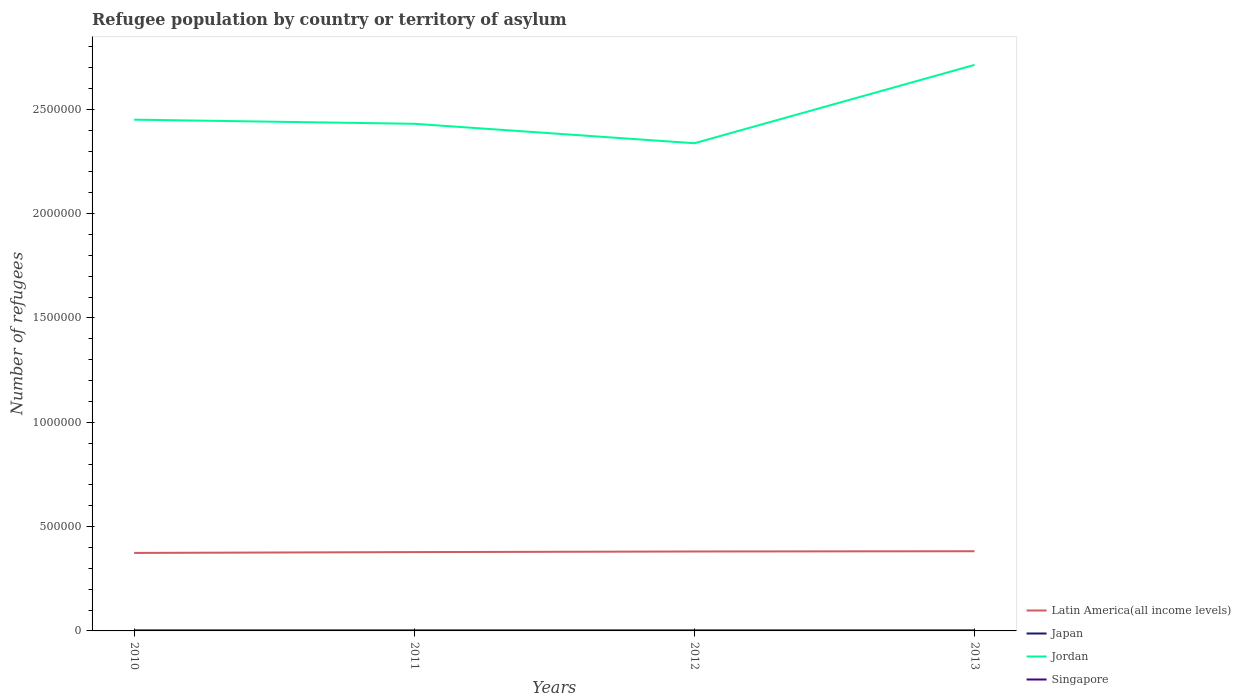Does the line corresponding to Japan intersect with the line corresponding to Jordan?
Your answer should be very brief. No. Is the number of lines equal to the number of legend labels?
Keep it short and to the point. Yes. Across all years, what is the maximum number of refugees in Latin America(all income levels)?
Your answer should be compact. 3.74e+05. What is the total number of refugees in Latin America(all income levels) in the graph?
Ensure brevity in your answer.  -1213. What is the difference between the highest and the second highest number of refugees in Japan?
Your answer should be compact. 68. How many lines are there?
Your answer should be compact. 4. Does the graph contain any zero values?
Give a very brief answer. No. Does the graph contain grids?
Provide a succinct answer. No. How are the legend labels stacked?
Your response must be concise. Vertical. What is the title of the graph?
Your answer should be compact. Refugee population by country or territory of asylum. Does "St. Vincent and the Grenadines" appear as one of the legend labels in the graph?
Provide a succinct answer. No. What is the label or title of the X-axis?
Ensure brevity in your answer.  Years. What is the label or title of the Y-axis?
Ensure brevity in your answer.  Number of refugees. What is the Number of refugees in Latin America(all income levels) in 2010?
Provide a succinct answer. 3.74e+05. What is the Number of refugees of Japan in 2010?
Keep it short and to the point. 2586. What is the Number of refugees in Jordan in 2010?
Your response must be concise. 2.45e+06. What is the Number of refugees of Singapore in 2010?
Give a very brief answer. 7. What is the Number of refugees of Latin America(all income levels) in 2011?
Offer a terse response. 3.78e+05. What is the Number of refugees of Japan in 2011?
Your answer should be very brief. 2649. What is the Number of refugees of Jordan in 2011?
Provide a succinct answer. 2.43e+06. What is the Number of refugees of Latin America(all income levels) in 2012?
Provide a short and direct response. 3.81e+05. What is the Number of refugees in Japan in 2012?
Keep it short and to the point. 2581. What is the Number of refugees in Jordan in 2012?
Your response must be concise. 2.34e+06. What is the Number of refugees in Latin America(all income levels) in 2013?
Give a very brief answer. 3.82e+05. What is the Number of refugees in Japan in 2013?
Make the answer very short. 2584. What is the Number of refugees of Jordan in 2013?
Provide a short and direct response. 2.71e+06. What is the Number of refugees of Singapore in 2013?
Ensure brevity in your answer.  3. Across all years, what is the maximum Number of refugees in Latin America(all income levels)?
Provide a succinct answer. 3.82e+05. Across all years, what is the maximum Number of refugees in Japan?
Provide a short and direct response. 2649. Across all years, what is the maximum Number of refugees in Jordan?
Ensure brevity in your answer.  2.71e+06. Across all years, what is the maximum Number of refugees of Singapore?
Provide a short and direct response. 7. Across all years, what is the minimum Number of refugees in Latin America(all income levels)?
Provide a succinct answer. 3.74e+05. Across all years, what is the minimum Number of refugees of Japan?
Ensure brevity in your answer.  2581. Across all years, what is the minimum Number of refugees in Jordan?
Your answer should be very brief. 2.34e+06. Across all years, what is the minimum Number of refugees in Singapore?
Your answer should be compact. 3. What is the total Number of refugees in Latin America(all income levels) in the graph?
Provide a succinct answer. 1.51e+06. What is the total Number of refugees of Japan in the graph?
Ensure brevity in your answer.  1.04e+04. What is the total Number of refugees in Jordan in the graph?
Offer a very short reply. 9.93e+06. What is the total Number of refugees in Singapore in the graph?
Offer a very short reply. 16. What is the difference between the Number of refugees of Latin America(all income levels) in 2010 and that in 2011?
Ensure brevity in your answer.  -3917. What is the difference between the Number of refugees of Japan in 2010 and that in 2011?
Ensure brevity in your answer.  -63. What is the difference between the Number of refugees in Jordan in 2010 and that in 2011?
Offer a terse response. 1.98e+04. What is the difference between the Number of refugees in Singapore in 2010 and that in 2011?
Your answer should be very brief. 4. What is the difference between the Number of refugees of Latin America(all income levels) in 2010 and that in 2012?
Your answer should be very brief. -6871. What is the difference between the Number of refugees in Jordan in 2010 and that in 2012?
Offer a terse response. 1.13e+05. What is the difference between the Number of refugees of Singapore in 2010 and that in 2012?
Offer a very short reply. 4. What is the difference between the Number of refugees of Latin America(all income levels) in 2010 and that in 2013?
Provide a short and direct response. -8084. What is the difference between the Number of refugees of Japan in 2010 and that in 2013?
Offer a terse response. 2. What is the difference between the Number of refugees of Jordan in 2010 and that in 2013?
Provide a short and direct response. -2.63e+05. What is the difference between the Number of refugees of Latin America(all income levels) in 2011 and that in 2012?
Your answer should be very brief. -2954. What is the difference between the Number of refugees of Japan in 2011 and that in 2012?
Your answer should be very brief. 68. What is the difference between the Number of refugees in Jordan in 2011 and that in 2012?
Provide a short and direct response. 9.32e+04. What is the difference between the Number of refugees in Singapore in 2011 and that in 2012?
Make the answer very short. 0. What is the difference between the Number of refugees of Latin America(all income levels) in 2011 and that in 2013?
Provide a succinct answer. -4167. What is the difference between the Number of refugees in Japan in 2011 and that in 2013?
Offer a very short reply. 65. What is the difference between the Number of refugees in Jordan in 2011 and that in 2013?
Make the answer very short. -2.82e+05. What is the difference between the Number of refugees of Latin America(all income levels) in 2012 and that in 2013?
Give a very brief answer. -1213. What is the difference between the Number of refugees of Jordan in 2012 and that in 2013?
Ensure brevity in your answer.  -3.76e+05. What is the difference between the Number of refugees in Singapore in 2012 and that in 2013?
Your answer should be very brief. 0. What is the difference between the Number of refugees in Latin America(all income levels) in 2010 and the Number of refugees in Japan in 2011?
Provide a succinct answer. 3.71e+05. What is the difference between the Number of refugees in Latin America(all income levels) in 2010 and the Number of refugees in Jordan in 2011?
Your answer should be very brief. -2.06e+06. What is the difference between the Number of refugees of Latin America(all income levels) in 2010 and the Number of refugees of Singapore in 2011?
Provide a succinct answer. 3.74e+05. What is the difference between the Number of refugees in Japan in 2010 and the Number of refugees in Jordan in 2011?
Your answer should be compact. -2.43e+06. What is the difference between the Number of refugees of Japan in 2010 and the Number of refugees of Singapore in 2011?
Your answer should be compact. 2583. What is the difference between the Number of refugees of Jordan in 2010 and the Number of refugees of Singapore in 2011?
Give a very brief answer. 2.45e+06. What is the difference between the Number of refugees in Latin America(all income levels) in 2010 and the Number of refugees in Japan in 2012?
Keep it short and to the point. 3.71e+05. What is the difference between the Number of refugees of Latin America(all income levels) in 2010 and the Number of refugees of Jordan in 2012?
Your answer should be very brief. -1.96e+06. What is the difference between the Number of refugees in Latin America(all income levels) in 2010 and the Number of refugees in Singapore in 2012?
Give a very brief answer. 3.74e+05. What is the difference between the Number of refugees of Japan in 2010 and the Number of refugees of Jordan in 2012?
Ensure brevity in your answer.  -2.33e+06. What is the difference between the Number of refugees in Japan in 2010 and the Number of refugees in Singapore in 2012?
Offer a terse response. 2583. What is the difference between the Number of refugees in Jordan in 2010 and the Number of refugees in Singapore in 2012?
Ensure brevity in your answer.  2.45e+06. What is the difference between the Number of refugees in Latin America(all income levels) in 2010 and the Number of refugees in Japan in 2013?
Your response must be concise. 3.71e+05. What is the difference between the Number of refugees in Latin America(all income levels) in 2010 and the Number of refugees in Jordan in 2013?
Offer a terse response. -2.34e+06. What is the difference between the Number of refugees of Latin America(all income levels) in 2010 and the Number of refugees of Singapore in 2013?
Offer a terse response. 3.74e+05. What is the difference between the Number of refugees of Japan in 2010 and the Number of refugees of Jordan in 2013?
Give a very brief answer. -2.71e+06. What is the difference between the Number of refugees in Japan in 2010 and the Number of refugees in Singapore in 2013?
Ensure brevity in your answer.  2583. What is the difference between the Number of refugees in Jordan in 2010 and the Number of refugees in Singapore in 2013?
Your response must be concise. 2.45e+06. What is the difference between the Number of refugees of Latin America(all income levels) in 2011 and the Number of refugees of Japan in 2012?
Give a very brief answer. 3.75e+05. What is the difference between the Number of refugees in Latin America(all income levels) in 2011 and the Number of refugees in Jordan in 2012?
Your response must be concise. -1.96e+06. What is the difference between the Number of refugees of Latin America(all income levels) in 2011 and the Number of refugees of Singapore in 2012?
Offer a terse response. 3.78e+05. What is the difference between the Number of refugees in Japan in 2011 and the Number of refugees in Jordan in 2012?
Ensure brevity in your answer.  -2.33e+06. What is the difference between the Number of refugees of Japan in 2011 and the Number of refugees of Singapore in 2012?
Offer a terse response. 2646. What is the difference between the Number of refugees of Jordan in 2011 and the Number of refugees of Singapore in 2012?
Make the answer very short. 2.43e+06. What is the difference between the Number of refugees in Latin America(all income levels) in 2011 and the Number of refugees in Japan in 2013?
Ensure brevity in your answer.  3.75e+05. What is the difference between the Number of refugees of Latin America(all income levels) in 2011 and the Number of refugees of Jordan in 2013?
Provide a short and direct response. -2.34e+06. What is the difference between the Number of refugees of Latin America(all income levels) in 2011 and the Number of refugees of Singapore in 2013?
Ensure brevity in your answer.  3.78e+05. What is the difference between the Number of refugees of Japan in 2011 and the Number of refugees of Jordan in 2013?
Ensure brevity in your answer.  -2.71e+06. What is the difference between the Number of refugees in Japan in 2011 and the Number of refugees in Singapore in 2013?
Provide a succinct answer. 2646. What is the difference between the Number of refugees in Jordan in 2011 and the Number of refugees in Singapore in 2013?
Offer a terse response. 2.43e+06. What is the difference between the Number of refugees of Latin America(all income levels) in 2012 and the Number of refugees of Japan in 2013?
Provide a succinct answer. 3.78e+05. What is the difference between the Number of refugees in Latin America(all income levels) in 2012 and the Number of refugees in Jordan in 2013?
Ensure brevity in your answer.  -2.33e+06. What is the difference between the Number of refugees in Latin America(all income levels) in 2012 and the Number of refugees in Singapore in 2013?
Give a very brief answer. 3.81e+05. What is the difference between the Number of refugees of Japan in 2012 and the Number of refugees of Jordan in 2013?
Offer a very short reply. -2.71e+06. What is the difference between the Number of refugees in Japan in 2012 and the Number of refugees in Singapore in 2013?
Your response must be concise. 2578. What is the difference between the Number of refugees of Jordan in 2012 and the Number of refugees of Singapore in 2013?
Your response must be concise. 2.34e+06. What is the average Number of refugees of Latin America(all income levels) per year?
Provide a succinct answer. 3.79e+05. What is the average Number of refugees in Japan per year?
Offer a very short reply. 2600. What is the average Number of refugees of Jordan per year?
Your response must be concise. 2.48e+06. What is the average Number of refugees in Singapore per year?
Provide a succinct answer. 4. In the year 2010, what is the difference between the Number of refugees of Latin America(all income levels) and Number of refugees of Japan?
Give a very brief answer. 3.71e+05. In the year 2010, what is the difference between the Number of refugees in Latin America(all income levels) and Number of refugees in Jordan?
Make the answer very short. -2.08e+06. In the year 2010, what is the difference between the Number of refugees of Latin America(all income levels) and Number of refugees of Singapore?
Give a very brief answer. 3.74e+05. In the year 2010, what is the difference between the Number of refugees in Japan and Number of refugees in Jordan?
Keep it short and to the point. -2.45e+06. In the year 2010, what is the difference between the Number of refugees of Japan and Number of refugees of Singapore?
Keep it short and to the point. 2579. In the year 2010, what is the difference between the Number of refugees in Jordan and Number of refugees in Singapore?
Provide a succinct answer. 2.45e+06. In the year 2011, what is the difference between the Number of refugees of Latin America(all income levels) and Number of refugees of Japan?
Offer a very short reply. 3.75e+05. In the year 2011, what is the difference between the Number of refugees in Latin America(all income levels) and Number of refugees in Jordan?
Give a very brief answer. -2.05e+06. In the year 2011, what is the difference between the Number of refugees in Latin America(all income levels) and Number of refugees in Singapore?
Keep it short and to the point. 3.78e+05. In the year 2011, what is the difference between the Number of refugees of Japan and Number of refugees of Jordan?
Make the answer very short. -2.43e+06. In the year 2011, what is the difference between the Number of refugees of Japan and Number of refugees of Singapore?
Give a very brief answer. 2646. In the year 2011, what is the difference between the Number of refugees in Jordan and Number of refugees in Singapore?
Provide a succinct answer. 2.43e+06. In the year 2012, what is the difference between the Number of refugees in Latin America(all income levels) and Number of refugees in Japan?
Your answer should be very brief. 3.78e+05. In the year 2012, what is the difference between the Number of refugees of Latin America(all income levels) and Number of refugees of Jordan?
Keep it short and to the point. -1.96e+06. In the year 2012, what is the difference between the Number of refugees in Latin America(all income levels) and Number of refugees in Singapore?
Offer a very short reply. 3.81e+05. In the year 2012, what is the difference between the Number of refugees of Japan and Number of refugees of Jordan?
Ensure brevity in your answer.  -2.33e+06. In the year 2012, what is the difference between the Number of refugees of Japan and Number of refugees of Singapore?
Make the answer very short. 2578. In the year 2012, what is the difference between the Number of refugees in Jordan and Number of refugees in Singapore?
Your response must be concise. 2.34e+06. In the year 2013, what is the difference between the Number of refugees in Latin America(all income levels) and Number of refugees in Japan?
Your answer should be compact. 3.79e+05. In the year 2013, what is the difference between the Number of refugees in Latin America(all income levels) and Number of refugees in Jordan?
Provide a succinct answer. -2.33e+06. In the year 2013, what is the difference between the Number of refugees in Latin America(all income levels) and Number of refugees in Singapore?
Provide a succinct answer. 3.82e+05. In the year 2013, what is the difference between the Number of refugees of Japan and Number of refugees of Jordan?
Your answer should be very brief. -2.71e+06. In the year 2013, what is the difference between the Number of refugees of Japan and Number of refugees of Singapore?
Your answer should be compact. 2581. In the year 2013, what is the difference between the Number of refugees in Jordan and Number of refugees in Singapore?
Ensure brevity in your answer.  2.71e+06. What is the ratio of the Number of refugees of Japan in 2010 to that in 2011?
Offer a terse response. 0.98. What is the ratio of the Number of refugees of Jordan in 2010 to that in 2011?
Make the answer very short. 1.01. What is the ratio of the Number of refugees in Singapore in 2010 to that in 2011?
Provide a succinct answer. 2.33. What is the ratio of the Number of refugees of Japan in 2010 to that in 2012?
Offer a very short reply. 1. What is the ratio of the Number of refugees in Jordan in 2010 to that in 2012?
Provide a succinct answer. 1.05. What is the ratio of the Number of refugees of Singapore in 2010 to that in 2012?
Your response must be concise. 2.33. What is the ratio of the Number of refugees of Latin America(all income levels) in 2010 to that in 2013?
Your answer should be very brief. 0.98. What is the ratio of the Number of refugees of Japan in 2010 to that in 2013?
Offer a terse response. 1. What is the ratio of the Number of refugees of Jordan in 2010 to that in 2013?
Provide a succinct answer. 0.9. What is the ratio of the Number of refugees of Singapore in 2010 to that in 2013?
Provide a short and direct response. 2.33. What is the ratio of the Number of refugees of Japan in 2011 to that in 2012?
Make the answer very short. 1.03. What is the ratio of the Number of refugees in Jordan in 2011 to that in 2012?
Make the answer very short. 1.04. What is the ratio of the Number of refugees of Japan in 2011 to that in 2013?
Provide a short and direct response. 1.03. What is the ratio of the Number of refugees in Jordan in 2011 to that in 2013?
Your answer should be very brief. 0.9. What is the ratio of the Number of refugees in Latin America(all income levels) in 2012 to that in 2013?
Your answer should be very brief. 1. What is the ratio of the Number of refugees in Japan in 2012 to that in 2013?
Provide a succinct answer. 1. What is the ratio of the Number of refugees in Jordan in 2012 to that in 2013?
Provide a short and direct response. 0.86. What is the difference between the highest and the second highest Number of refugees of Latin America(all income levels)?
Give a very brief answer. 1213. What is the difference between the highest and the second highest Number of refugees of Japan?
Provide a succinct answer. 63. What is the difference between the highest and the second highest Number of refugees in Jordan?
Offer a very short reply. 2.63e+05. What is the difference between the highest and the second highest Number of refugees of Singapore?
Your answer should be compact. 4. What is the difference between the highest and the lowest Number of refugees of Latin America(all income levels)?
Keep it short and to the point. 8084. What is the difference between the highest and the lowest Number of refugees in Jordan?
Provide a short and direct response. 3.76e+05. What is the difference between the highest and the lowest Number of refugees in Singapore?
Give a very brief answer. 4. 